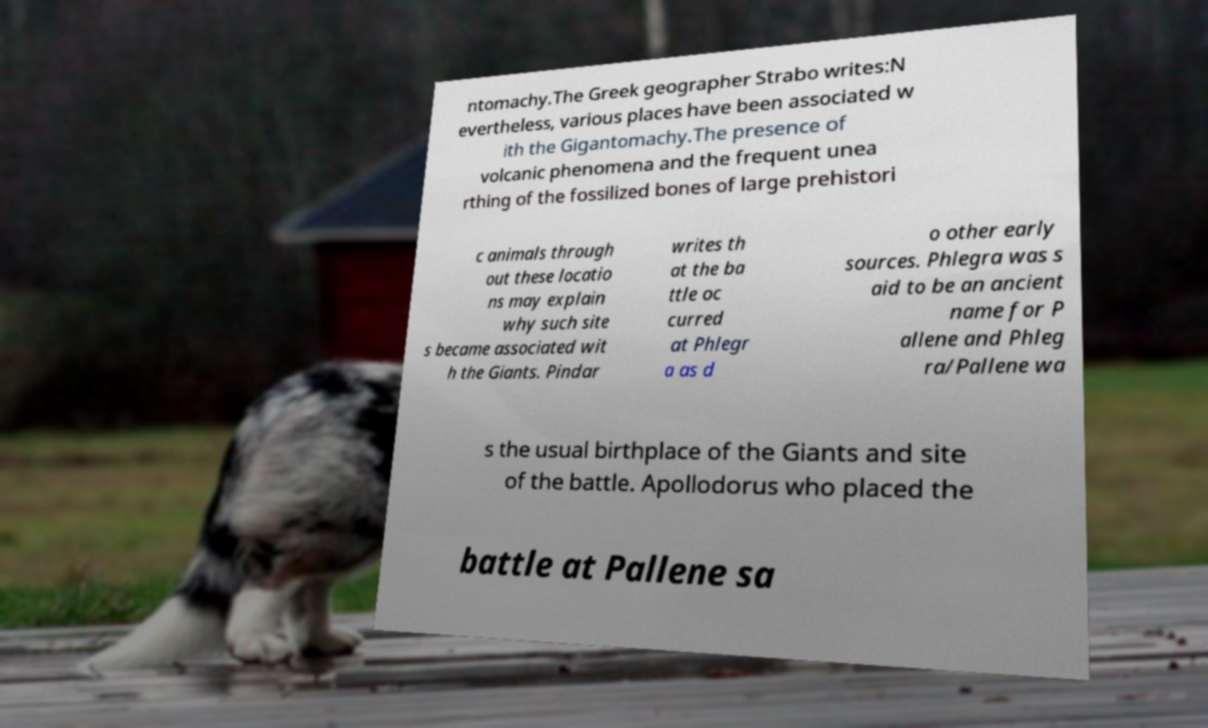Please read and relay the text visible in this image. What does it say? ntomachy.The Greek geographer Strabo writes:N evertheless, various places have been associated w ith the Gigantomachy.The presence of volcanic phenomena and the frequent unea rthing of the fossilized bones of large prehistori c animals through out these locatio ns may explain why such site s became associated wit h the Giants. Pindar writes th at the ba ttle oc curred at Phlegr a as d o other early sources. Phlegra was s aid to be an ancient name for P allene and Phleg ra/Pallene wa s the usual birthplace of the Giants and site of the battle. Apollodorus who placed the battle at Pallene sa 